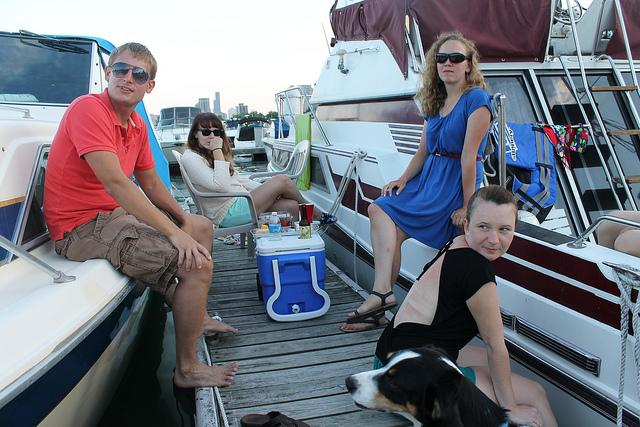Clothing items are hung here for which purpose?

Choices:
A) warning
B) signaling
C) drying
D) sale display drying 